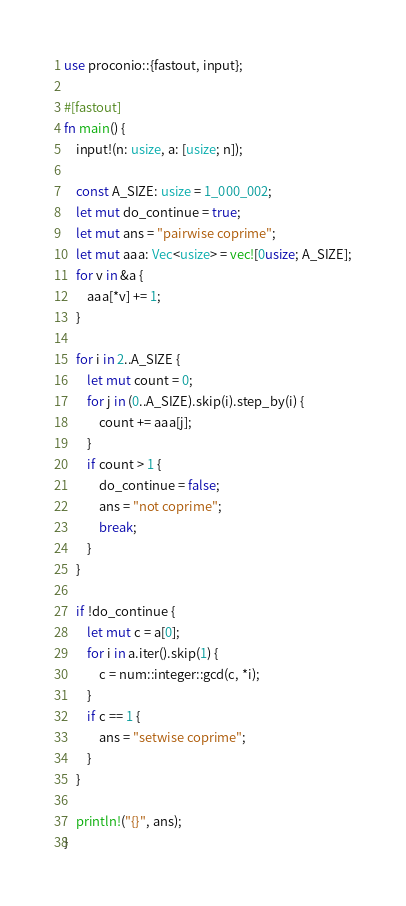<code> <loc_0><loc_0><loc_500><loc_500><_Rust_>use proconio::{fastout, input};

#[fastout]
fn main() {
    input!(n: usize, a: [usize; n]);

    const A_SIZE: usize = 1_000_002;
    let mut do_continue = true;
    let mut ans = "pairwise coprime";
    let mut aaa: Vec<usize> = vec![0usize; A_SIZE];
    for v in &a {
        aaa[*v] += 1;
    }

    for i in 2..A_SIZE {
        let mut count = 0;
        for j in (0..A_SIZE).skip(i).step_by(i) {
            count += aaa[j];
        }
        if count > 1 {
            do_continue = false;
            ans = "not coprime";
            break;
        }
    }

    if !do_continue {
        let mut c = a[0];
        for i in a.iter().skip(1) {
            c = num::integer::gcd(c, *i);
        }
        if c == 1 {
            ans = "setwise coprime";
        }
    }

    println!("{}", ans);
}
</code> 